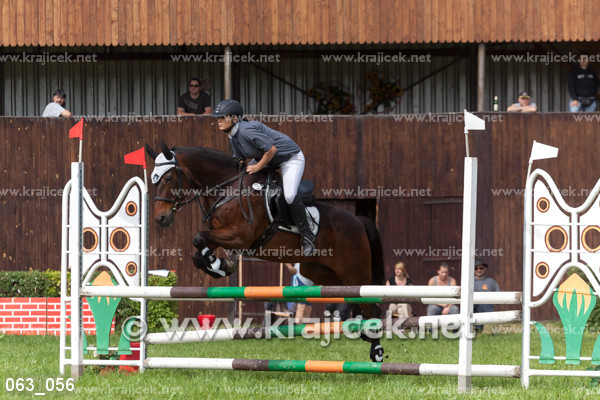Which bar is the horse meant to pass over?
A. top bar
B. right vertical
C. left vertical
D. bottom The horse is meant to clear the top bar during this jumping event. Unlike the other options which are not in the trajectory of the horse's jump, the top bar is the one that the rider aims to have the horse leap over without dislodging it. 